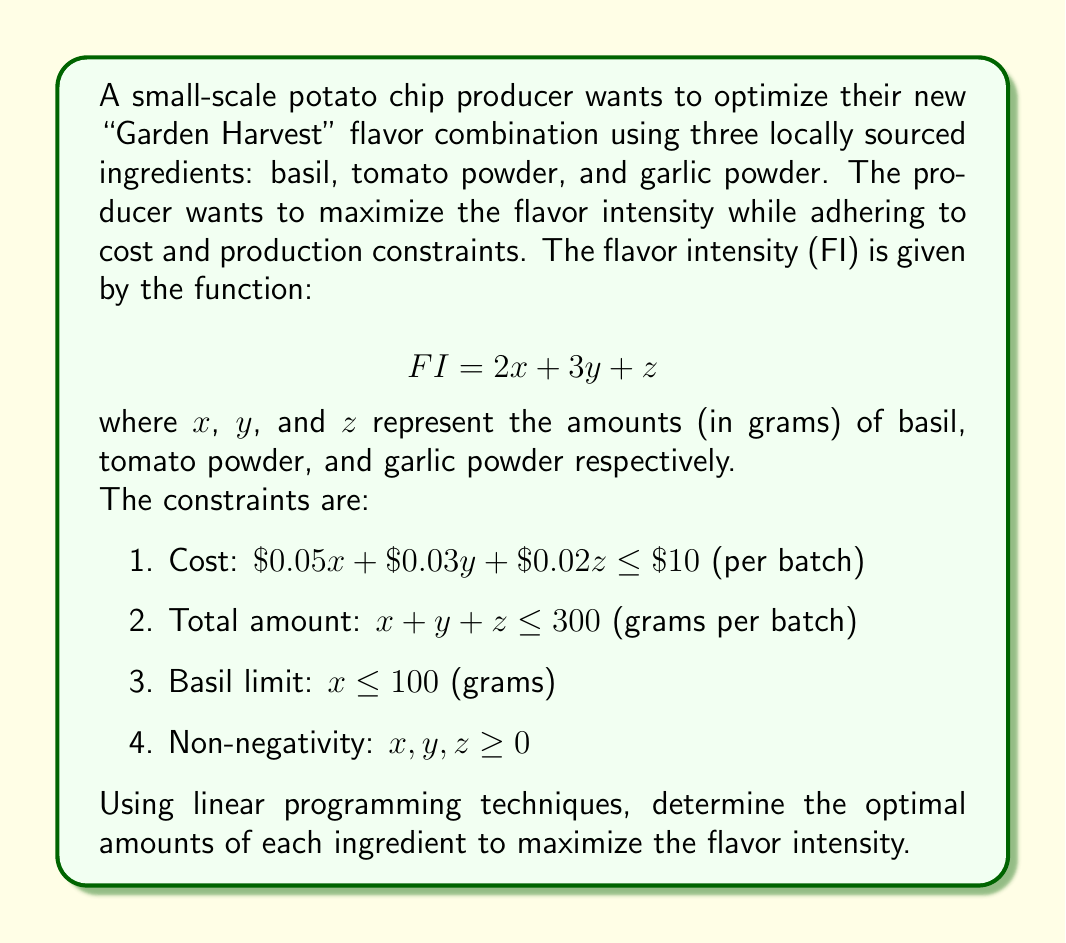Provide a solution to this math problem. To solve this linear programming problem, we'll use the simplex method:

1. First, convert the problem to standard form by introducing slack variables:

   Maximize: $Z = 2x + 3y + z$
   Subject to:
   $0.05x + 0.03y + 0.02z + s_1 = 10$
   $x + y + z + s_2 = 300$
   $x + s_3 = 100$
   $x, y, z, s_1, s_2, s_3 \geq 0$

2. Set up the initial simplex tableau:

   $$
   \begin{array}{c|cccccc|c}
    & x & y & z & s_1 & s_2 & s_3 & RHS \\
   \hline
   s_1 & 0.05 & 0.03 & 0.02 & 1 & 0 & 0 & 10 \\
   s_2 & 1 & 1 & 1 & 0 & 1 & 0 & 300 \\
   s_3 & 1 & 0 & 0 & 0 & 0 & 1 & 100 \\
   \hline
   Z & -2 & -3 & -1 & 0 & 0 & 0 & 0
   \end{array}
   $$

3. Identify the pivot column (most negative Z-row entry): $y$ (coefficient -3)

4. Calculate the ratios for the pivot row:
   $10 / 0.03 = 333.33$
   $300 / 1 = 300$
   $100 / 0 = \infty$

   The smallest ratio is 300, so the pivot row is the second row.

5. Perform row operations to make the pivot element 1 and other elements in the column 0:

   $$
   \begin{array}{c|cccccc|c}
    & x & y & z & s_1 & s_2 & s_3 & RHS \\
   \hline
   s_1 & 0.02 & 0 & 0.01 & 1 & -0.03 & 0 & 1 \\
   y & 1 & 1 & 1 & 0 & 1 & 0 & 300 \\
   s_3 & 1 & 0 & 0 & 0 & 0 & 1 & 100 \\
   \hline
   Z & 1 & 0 & 2 & 0 & 3 & 0 & 900
   \end{array}
   $$

6. Repeat steps 3-5 until there are no negative entries in the Z-row.

7. The final tableau is:

   $$
   \begin{array}{c|cccccc|c}
    & x & y & z & s_1 & s_2 & s_3 & RHS \\
   \hline
   s_1 & 0 & 0 & 0 & 1 & -0.03 & -0.02 & 3 \\
   y & 0 & 1 & 0 & 0 & 1 & -1 & 200 \\
   z & 0 & 0 & 1 & 0 & 0 & -1 & 100 \\
   \hline
   Z & 0 & 0 & 0 & 0 & 3 & -2 & 1000
   \end{array}
   $$

8. Reading the solution from the final tableau:
   $x = 0$, $y = 200$, $z = 100$

Therefore, the optimal solution is to use 200 grams of tomato powder and 100 grams of garlic powder, with no basil. This gives a maximum flavor intensity of 1000.
Answer: The optimal amounts of ingredients are:
Basil (x): 0 grams
Tomato powder (y): 200 grams
Garlic powder (z): 100 grams
Maximum flavor intensity: 1000 